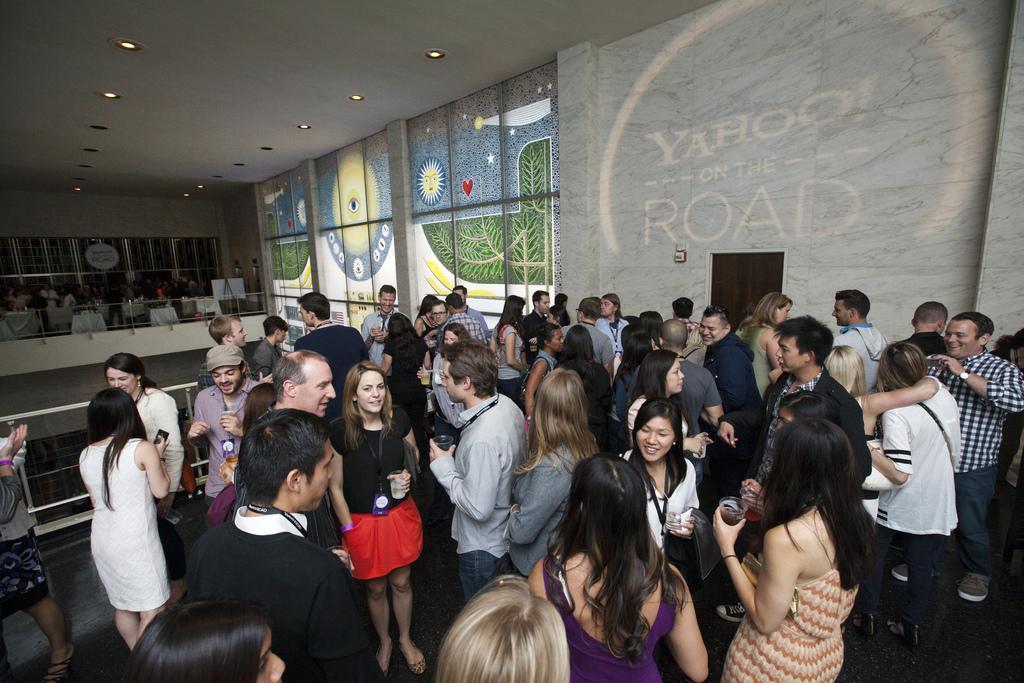Please provide a concise description of this image. In this image we can see a group of people standing on the floor, some people are holding glasses in their hands. On the left side of the image we can see railings, tables and some boards. On the right side of the image we can see some pictures and some text on the wall, we can also see a door. At the top of the image we can see some lights on the roof. 